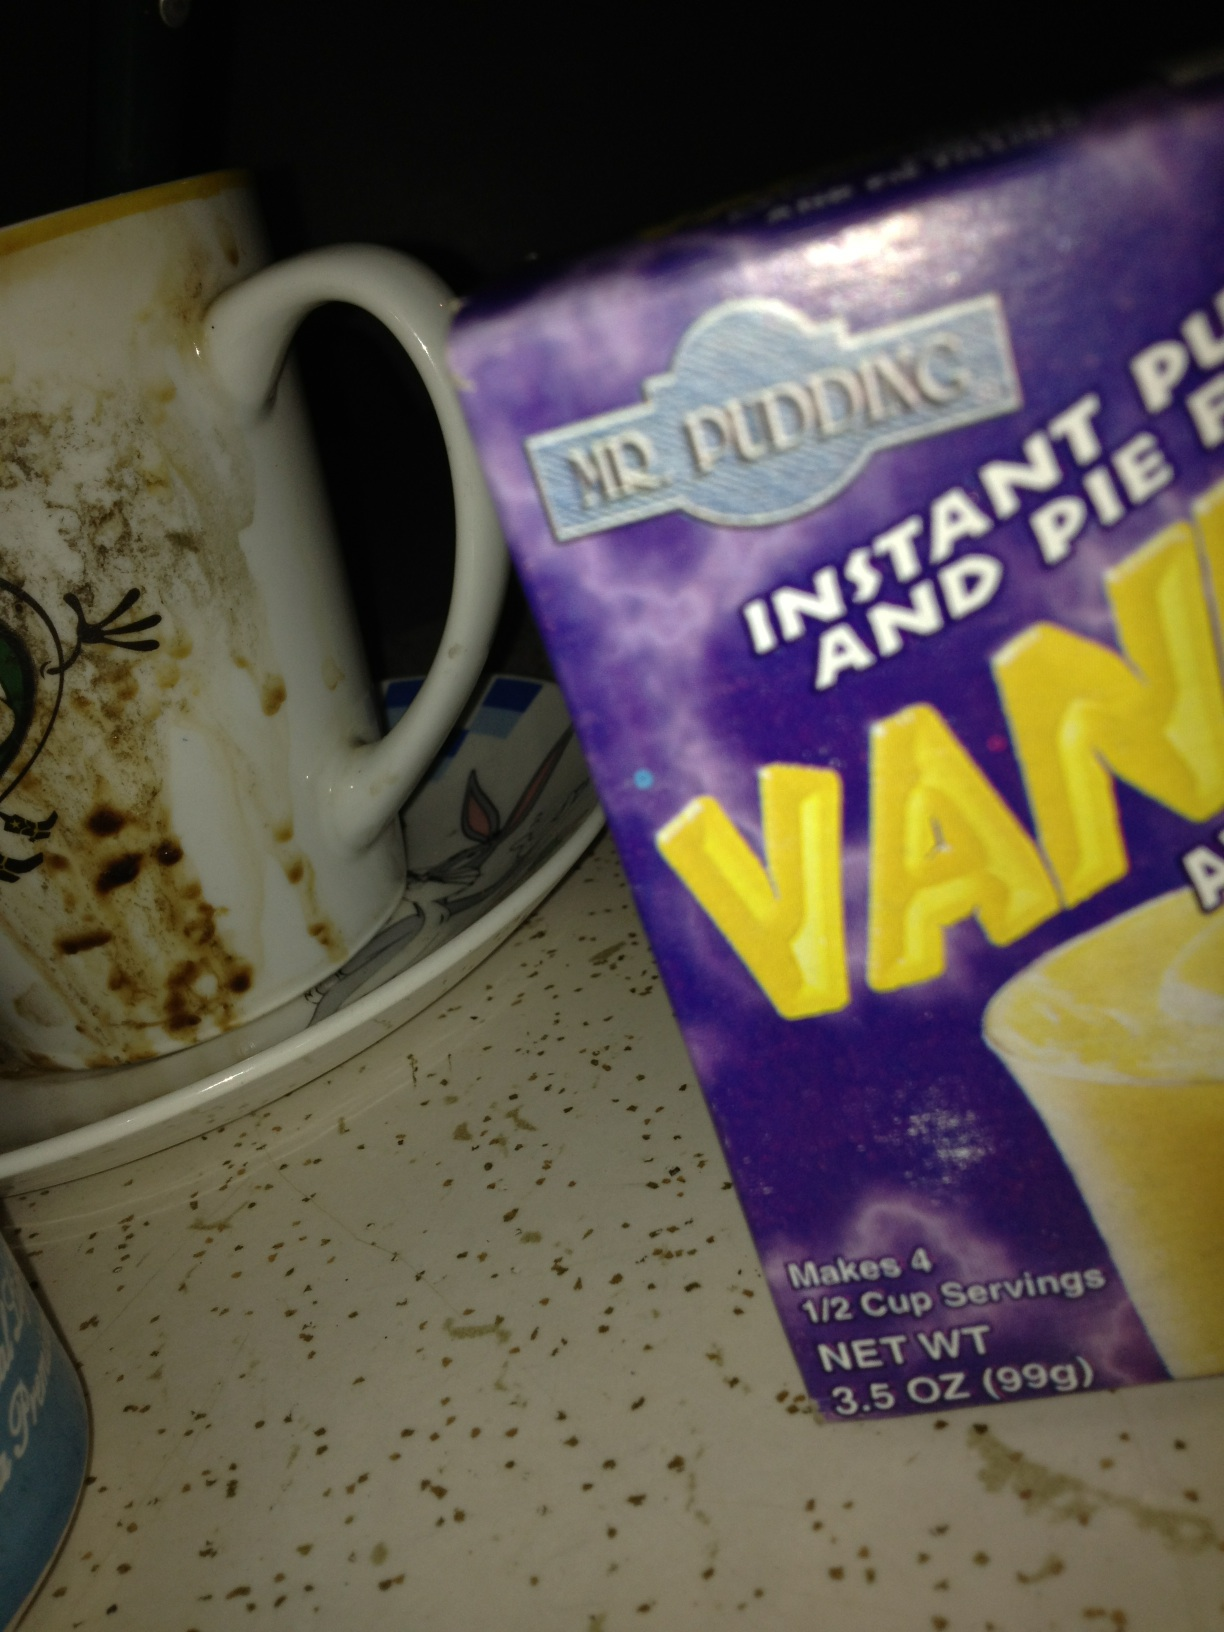What's in this box? The box contains instant vanilla pudding and pie filling mix, specifically it is 'Mr. Pudding' branded and it can make four half-cup servings. The net weight of the contents is 3.5 ounces or approximately 99 grams. 